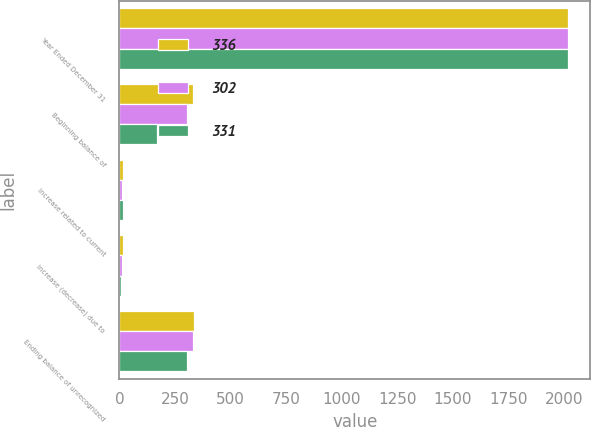Convert chart to OTSL. <chart><loc_0><loc_0><loc_500><loc_500><stacked_bar_chart><ecel><fcel>Year Ended December 31<fcel>Beginning balance of<fcel>Increase related to current<fcel>Increase (decrease) due to<fcel>Ending balance of unrecognized<nl><fcel>336<fcel>2018<fcel>331<fcel>17<fcel>17<fcel>336<nl><fcel>302<fcel>2017<fcel>302<fcel>13<fcel>11<fcel>331<nl><fcel>331<fcel>2016<fcel>168<fcel>17<fcel>6<fcel>302<nl></chart> 